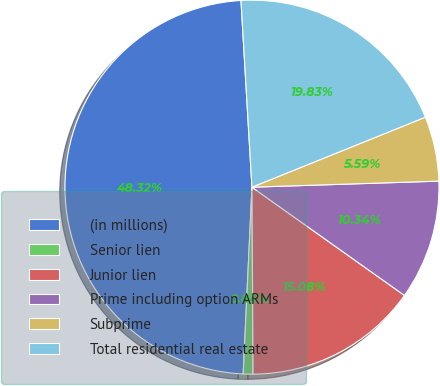<chart> <loc_0><loc_0><loc_500><loc_500><pie_chart><fcel>(in millions)<fcel>Senior lien<fcel>Junior lien<fcel>Prime including option ARMs<fcel>Subprime<fcel>Total residential real estate<nl><fcel>48.32%<fcel>0.84%<fcel>15.08%<fcel>10.34%<fcel>5.59%<fcel>19.83%<nl></chart> 